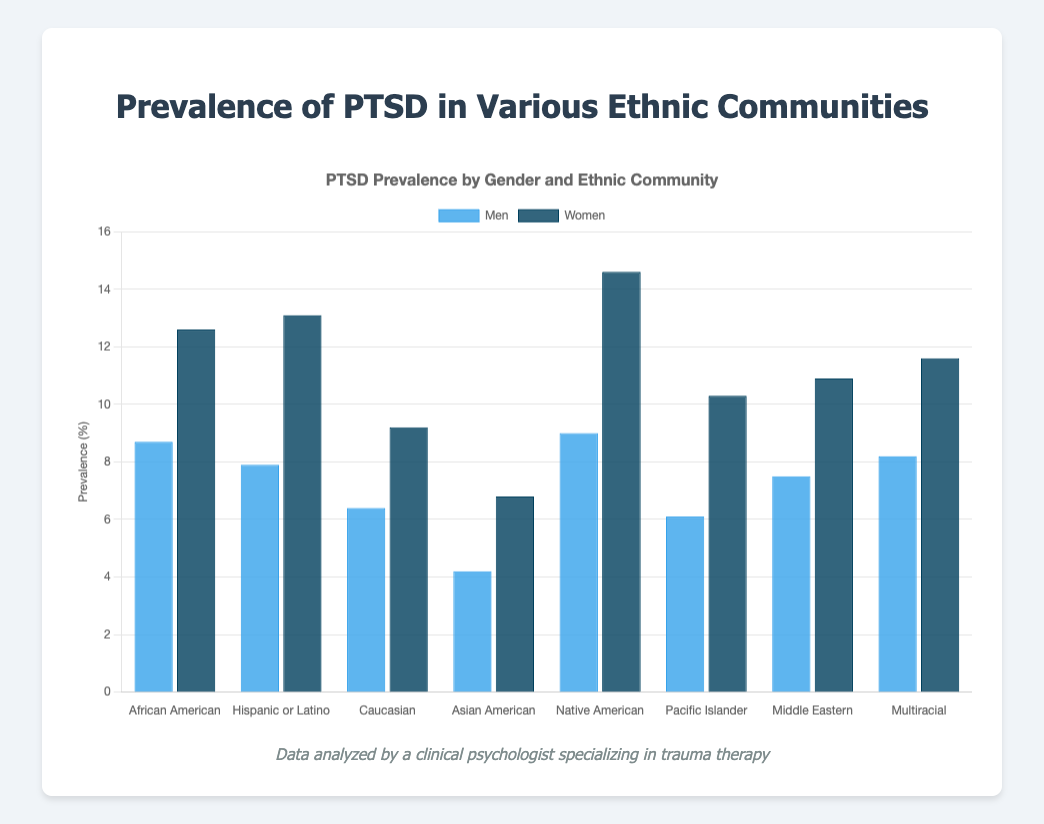Which ethnic community has the highest prevalence of PTSD among women? First, identify the highest bar representing women in the chart. The tallest bar for women corresponds to the Native American community, with a value of 14.6.
Answer: Native American How much higher is the prevalence of PTSD in women compared to men in the Hispanic or Latino community? Look at the prevalence values for both men and women in the Hispanic or Latino community, which are 7.9 for men and 13.1 for women. Subtract the men's prevalence from the women's prevalence: 13.1 - 7.9 = 5.2.
Answer: 5.2 What is the sum of the PTSD prevalence rates for men in the African American and Caucasian communities? Identify and sum the values for men in the African American (8.7) and Caucasian (6.4) communities: 8.7 + 6.4 = 15.1.
Answer: 15.1 Which gender has a higher overall average prevalence of PTSD across all ethnic communities? Sum the prevalence rates for men (8.7 + 7.9 + 6.4 + 4.2 + 9.0 + 6.1 + 7.5 + 8.2) and women (12.6 + 13.1 + 9.2 + 6.8 + 14.6 + 10.3 + 10.9 + 11.6), and then divide by the number of communities (8). Calculate: Men (58/8 = 7.25), Women (89.1/8 = 11.14). Compare the averages: women have a higher average.
Answer: Women Which community shows the smallest difference between men's and women's prevalence rates of PTSD? Calculate the differences for each community: 
African American (12.6 - 8.7 = 3.9), Hispanic or Latino (13.1 - 7.9 = 5.2), Caucasian (9.2 - 6.4 = 2.8), Asian American (6.8 - 4.2 = 2.6), Native American (14.6 - 9.0 = 5.6), Pacific Islander (10.3 - 6.1 = 4.2), Middle Eastern (10.9 - 7.5 = 3.4), Multiracial (11.6 - 8.2 = 3.4). The smallest difference is in the Asian American community.
Answer: Asian American Among the communities presented, which one has the closest prevalence rates of PTSD for both genders? Identify the community where the difference between men's and women's prevalence rates is the smallest. The difference for Asian American is the smallest (2.6).
Answer: Asian American Which community's men have the lowest prevalence of PTSD? Find the shortest blue bar representing men. The lowest value is for Asian American men, which is 4.2.
Answer: Asian American How does the PTSD prevalence for men in the Middle Eastern community compare to that in the Multiracial community? Compare the heights of the blue bars for Middle Eastern (7.5) and Multiracial (8.2). The prevalence rate for men in the Multiracial community is higher than in the Middle Eastern community.
Answer: Multiracial is higher What's the total PTSD prevalence for Native American men and women combined? Add the prevalence rates for men and women in the Native American community: 9.0 (men) + 14.6 (women) = 23.6.
Answer: 23.6 